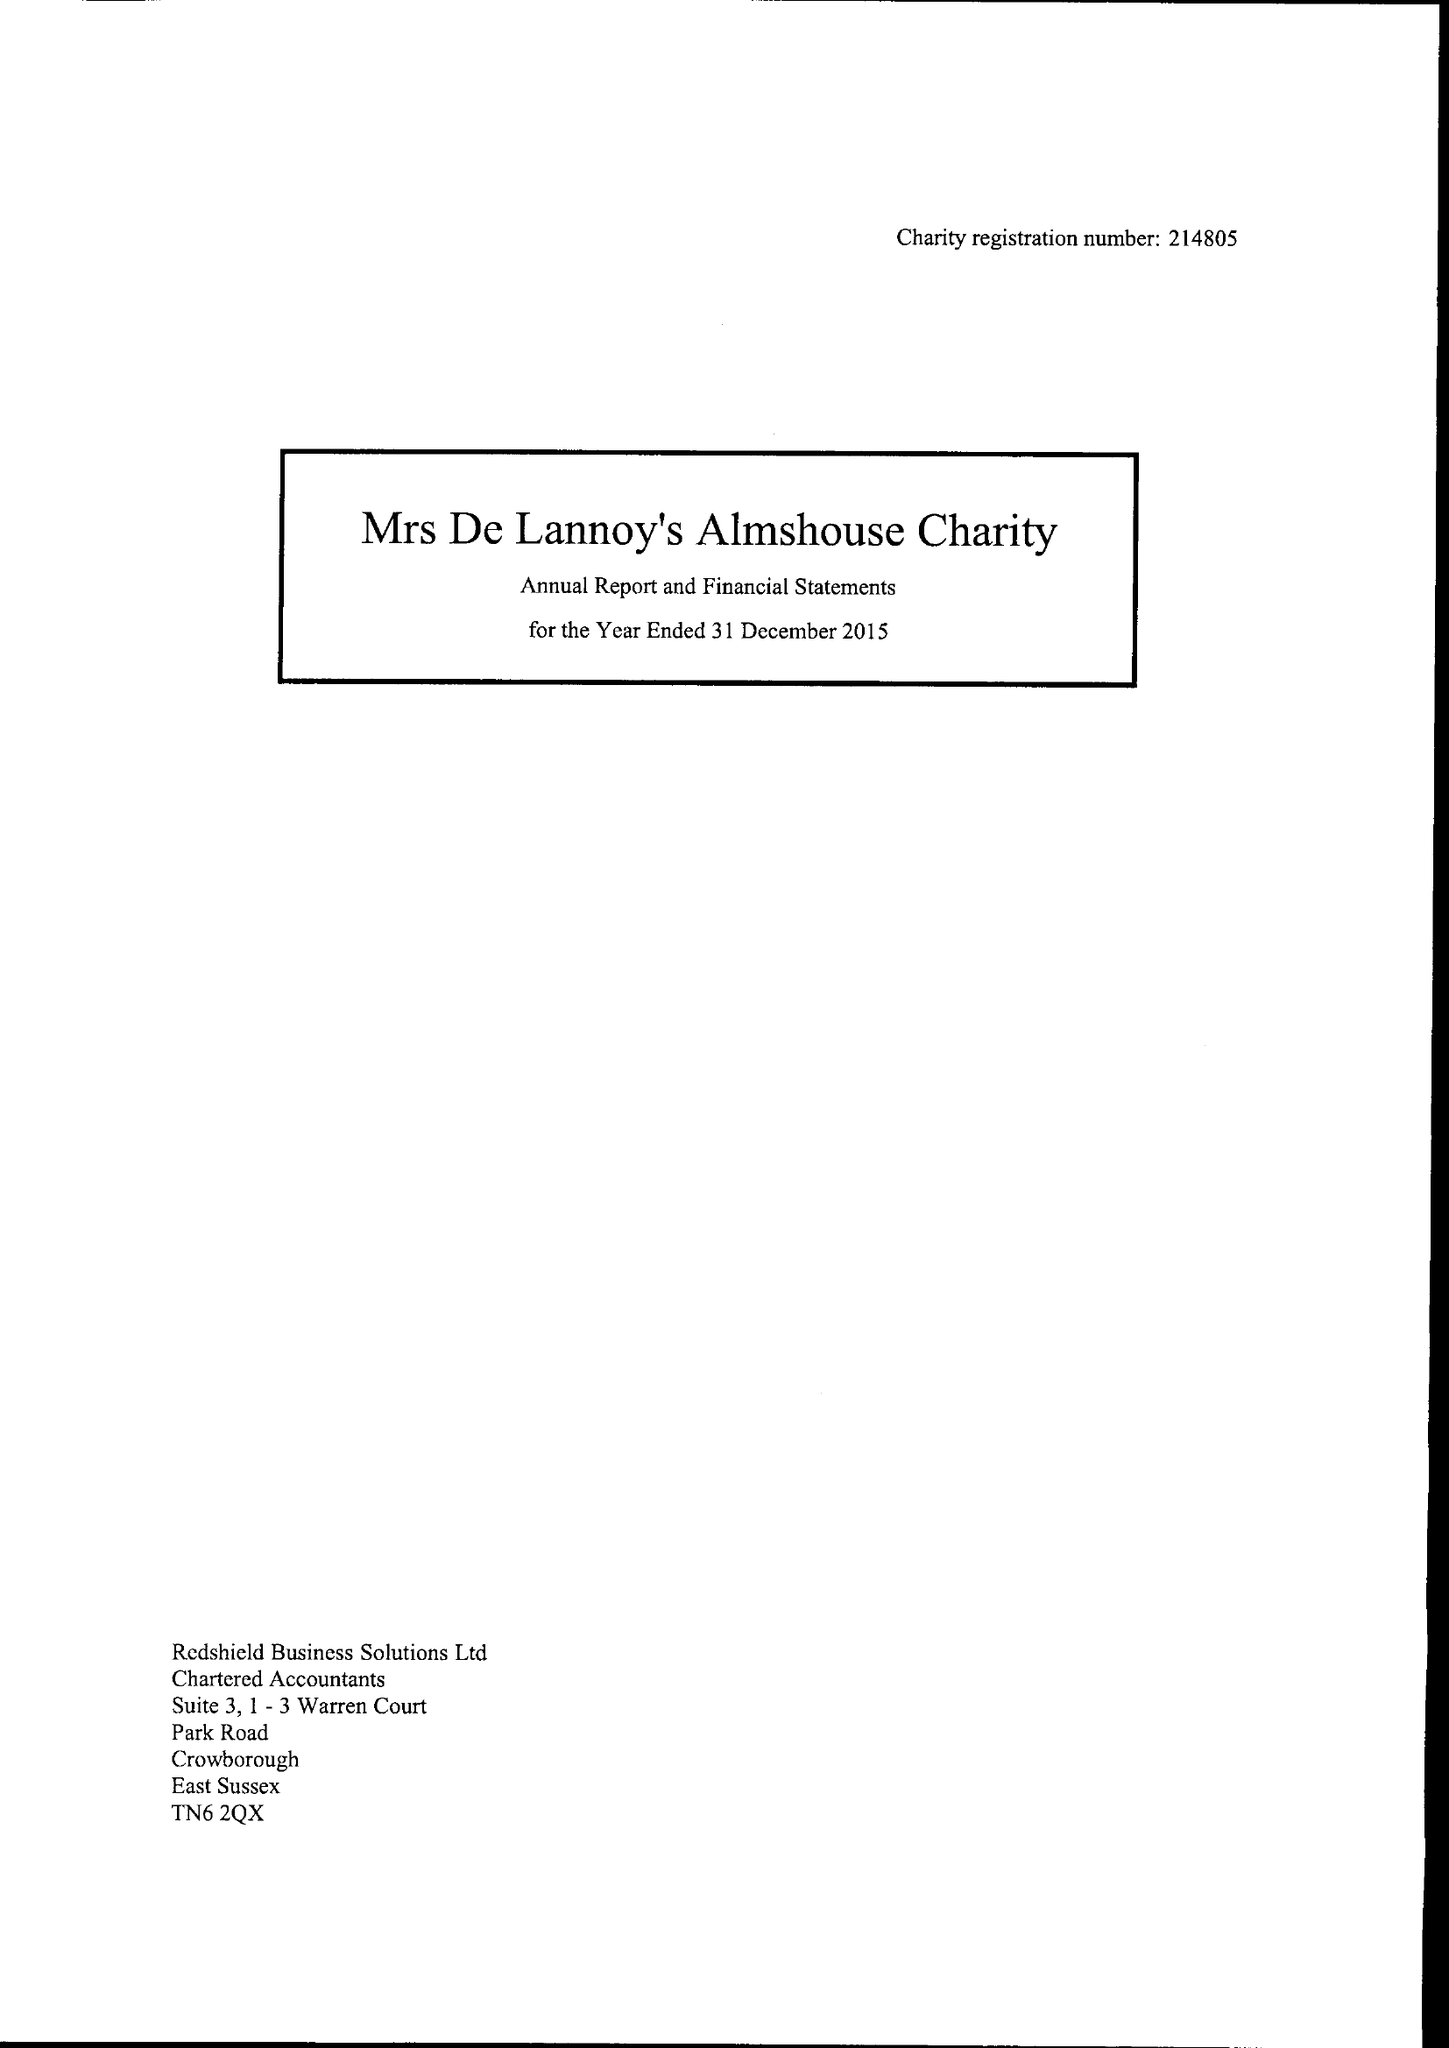What is the value for the report_date?
Answer the question using a single word or phrase. 2015-12-31 